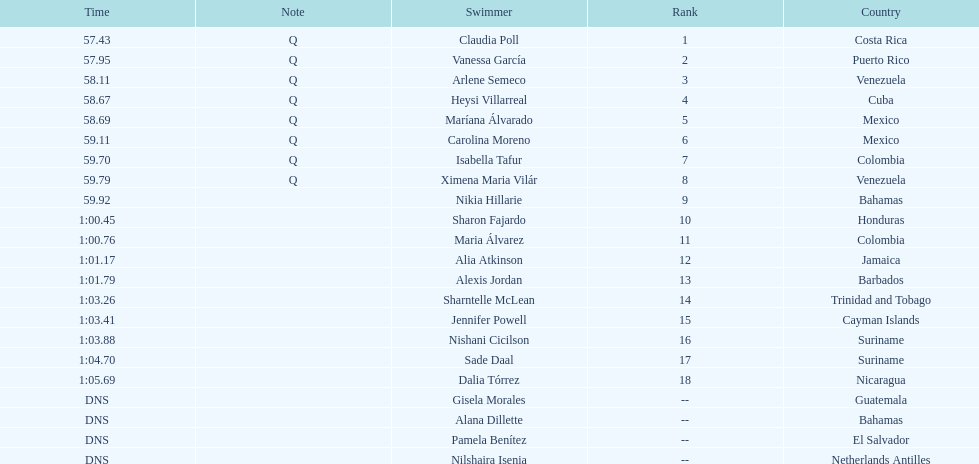How many mexican swimmers ranked in the top 10? 2. 